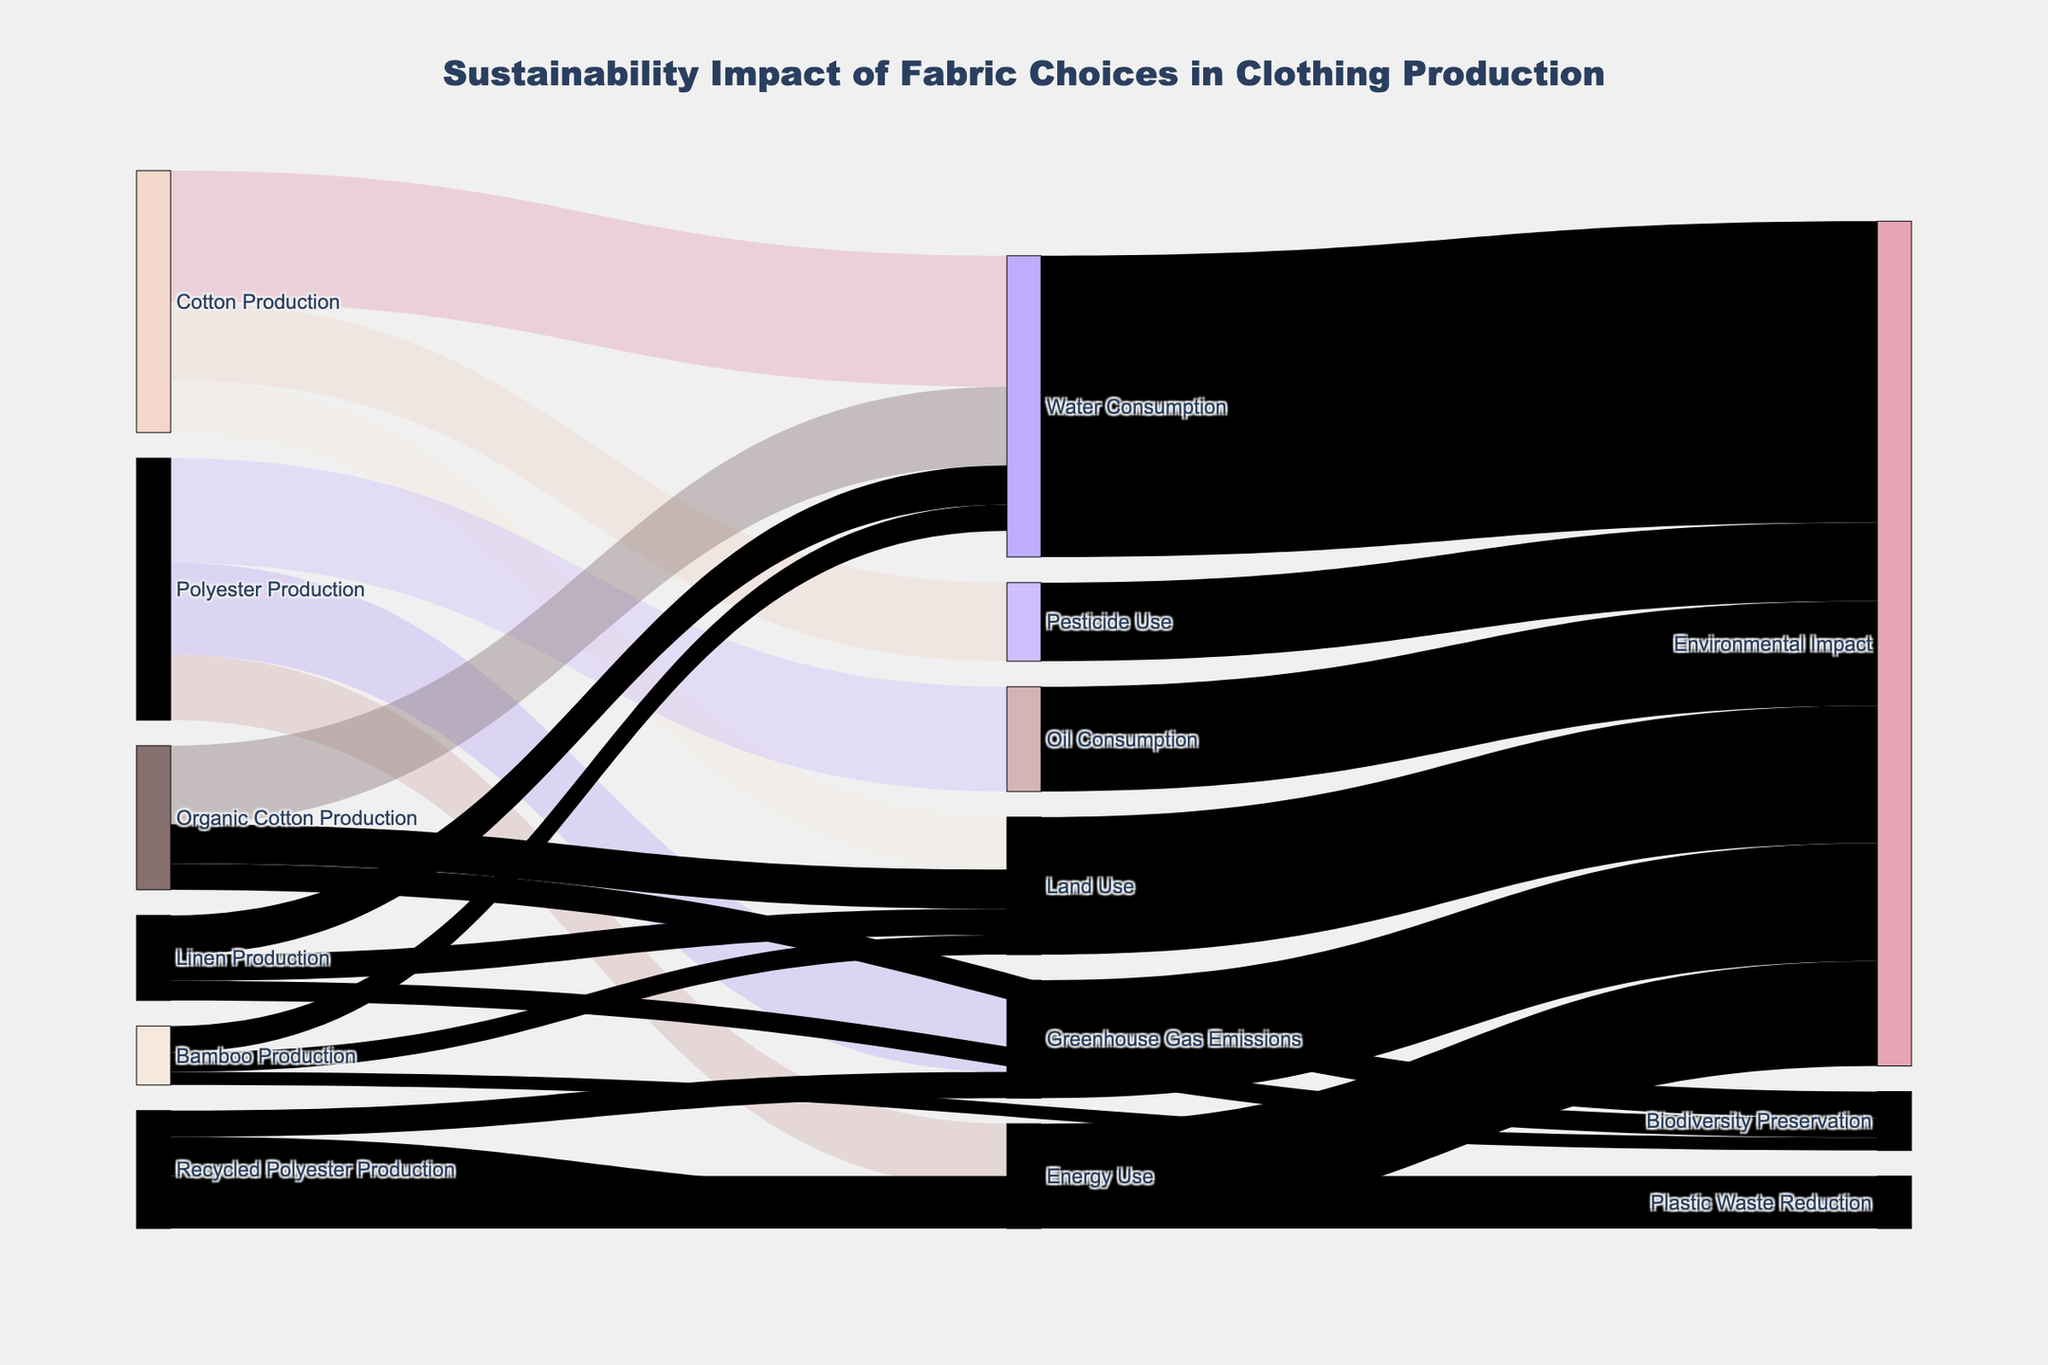what is the title of the diagram? The title can be found at the top of the diagram, it gives an overall context.
Answer: Sustainability Impact of Fabric Choices in Clothing Production Which fabric production results in the highest water consumption? By looking at the links labeled with water consumption, find the fabric production with the largest value.
Answer: Cotton Production What is the total environmental impact resulting from energy use? Summing up all links connecting Energy Use to Environmental Impact shows the total impact.
Answer: 400 Which type of fabric production contributes the least to land use? Compare the values associated with land use across different fabric types.
Answer: Bamboo Production What are the total contributions to environmental impact from cotton production? Add up contributions from all categories (Water Consumption, Pesticide Use, Land Use) under Cotton Production.
Answer: 500 + 300 + 200 = 1000 Describe the relationship between recycled polyester production and environmental impact. Identify the categories linked to recycled polyester production and their corresponding values, sum up for a broader view.
Answer: Plastic Waste Reduction (-200), Energy Use (150), Greenhouse Gas Emissions (100) resulting in a net positive impact of 50 How does organic cotton production compare with conventional cotton production in terms of water consumption? Check the water consumption values for both organic and conventional cotton production for comparison.
Answer: Organic Cotton Production: 300; Cotton Production: 500 What is the total biodiversity preservation impact from fabric productions? Sum the values for biodiversity preservation from all relevant fabric production types.
Answer: Organic Cotton Production (100) + Linen Production (75) + Bamboo Production (50) = 225 Which category has the highest negative environmental impact? Among categories contributing negatively to environmental impact, find the one with the highest value.
Answer: Biodiversity Preservation 